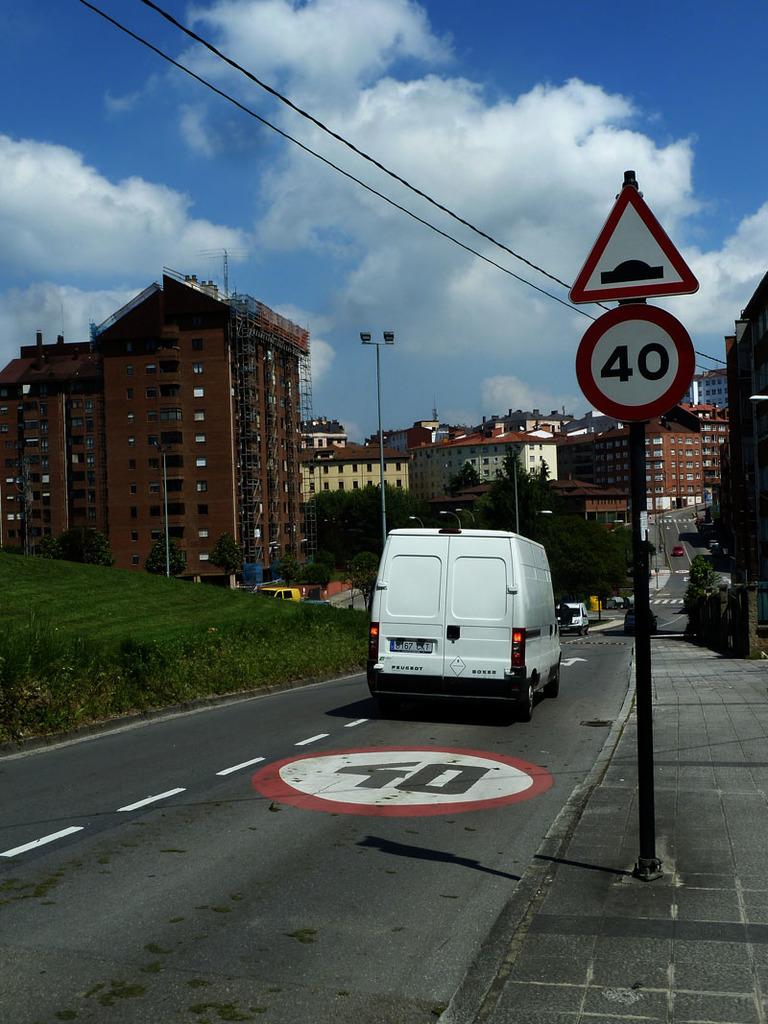What is the speed limit on this road?
Provide a short and direct response. 40. 